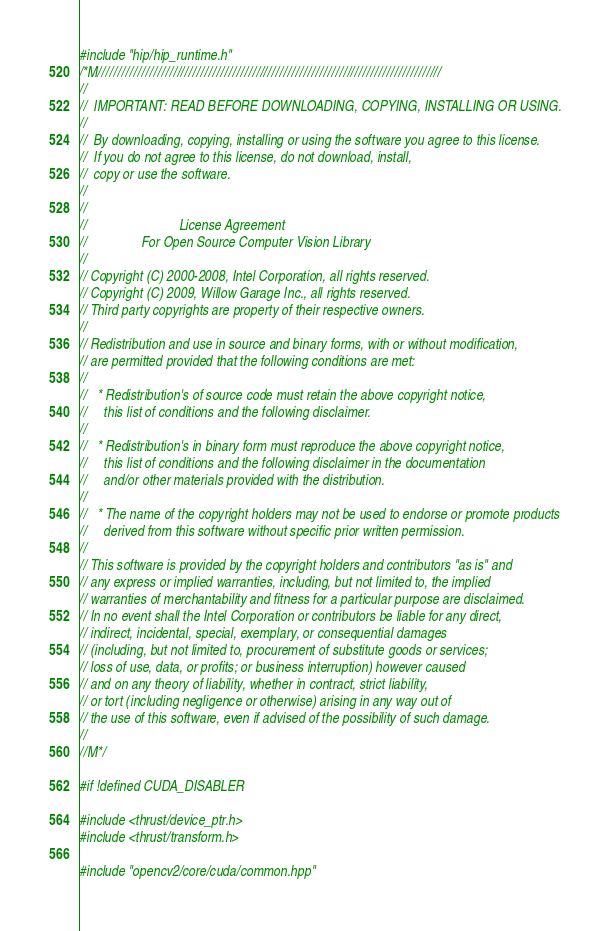<code> <loc_0><loc_0><loc_500><loc_500><_Cuda_>#include "hip/hip_runtime.h"
/*M///////////////////////////////////////////////////////////////////////////////////////
//
//  IMPORTANT: READ BEFORE DOWNLOADING, COPYING, INSTALLING OR USING.
//
//  By downloading, copying, installing or using the software you agree to this license.
//  If you do not agree to this license, do not download, install,
//  copy or use the software.
//
//
//                           License Agreement
//                For Open Source Computer Vision Library
//
// Copyright (C) 2000-2008, Intel Corporation, all rights reserved.
// Copyright (C) 2009, Willow Garage Inc., all rights reserved.
// Third party copyrights are property of their respective owners.
//
// Redistribution and use in source and binary forms, with or without modification,
// are permitted provided that the following conditions are met:
//
//   * Redistribution's of source code must retain the above copyright notice,
//     this list of conditions and the following disclaimer.
//
//   * Redistribution's in binary form must reproduce the above copyright notice,
//     this list of conditions and the following disclaimer in the documentation
//     and/or other materials provided with the distribution.
//
//   * The name of the copyright holders may not be used to endorse or promote products
//     derived from this software without specific prior written permission.
//
// This software is provided by the copyright holders and contributors "as is" and
// any express or implied warranties, including, but not limited to, the implied
// warranties of merchantability and fitness for a particular purpose are disclaimed.
// In no event shall the Intel Corporation or contributors be liable for any direct,
// indirect, incidental, special, exemplary, or consequential damages
// (including, but not limited to, procurement of substitute goods or services;
// loss of use, data, or profits; or business interruption) however caused
// and on any theory of liability, whether in contract, strict liability,
// or tort (including negligence or otherwise) arising in any way out of
// the use of this software, even if advised of the possibility of such damage.
//
//M*/

#if !defined CUDA_DISABLER

#include <thrust/device_ptr.h>
#include <thrust/transform.h>

#include "opencv2/core/cuda/common.hpp"</code> 